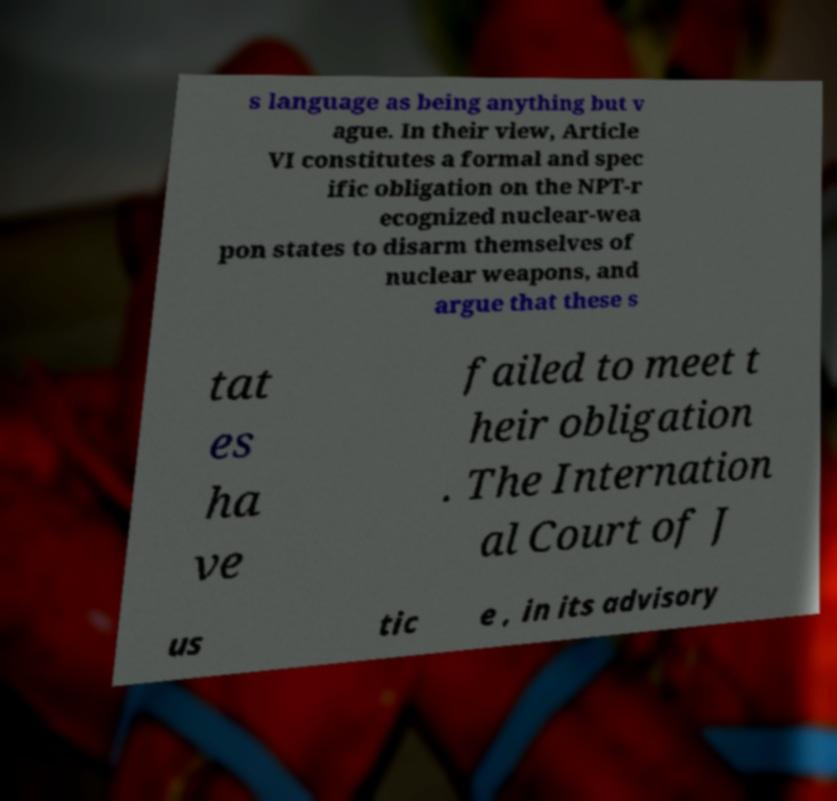Can you accurately transcribe the text from the provided image for me? s language as being anything but v ague. In their view, Article VI constitutes a formal and spec ific obligation on the NPT-r ecognized nuclear-wea pon states to disarm themselves of nuclear weapons, and argue that these s tat es ha ve failed to meet t heir obligation . The Internation al Court of J us tic e , in its advisory 